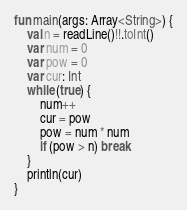<code> <loc_0><loc_0><loc_500><loc_500><_Kotlin_>fun main(args: Array<String>) {
    val n = readLine()!!.toInt()
    var num = 0
    var pow = 0
    var cur: Int
    while (true) {
        num++
        cur = pow
        pow = num * num
        if (pow > n) break
    }
    println(cur)
}</code> 